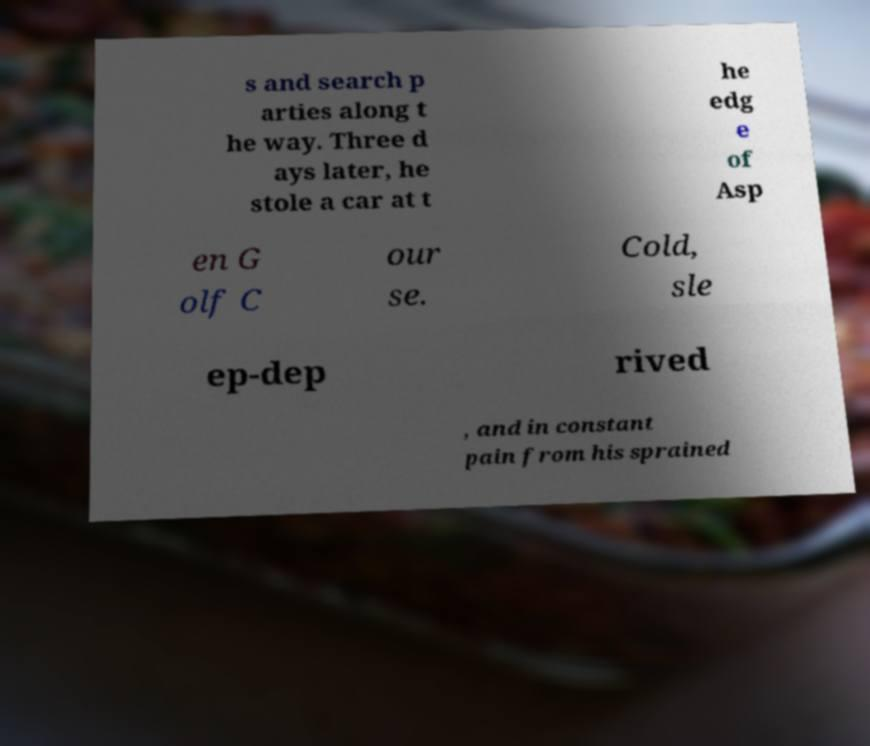Could you assist in decoding the text presented in this image and type it out clearly? s and search p arties along t he way. Three d ays later, he stole a car at t he edg e of Asp en G olf C our se. Cold, sle ep-dep rived , and in constant pain from his sprained 